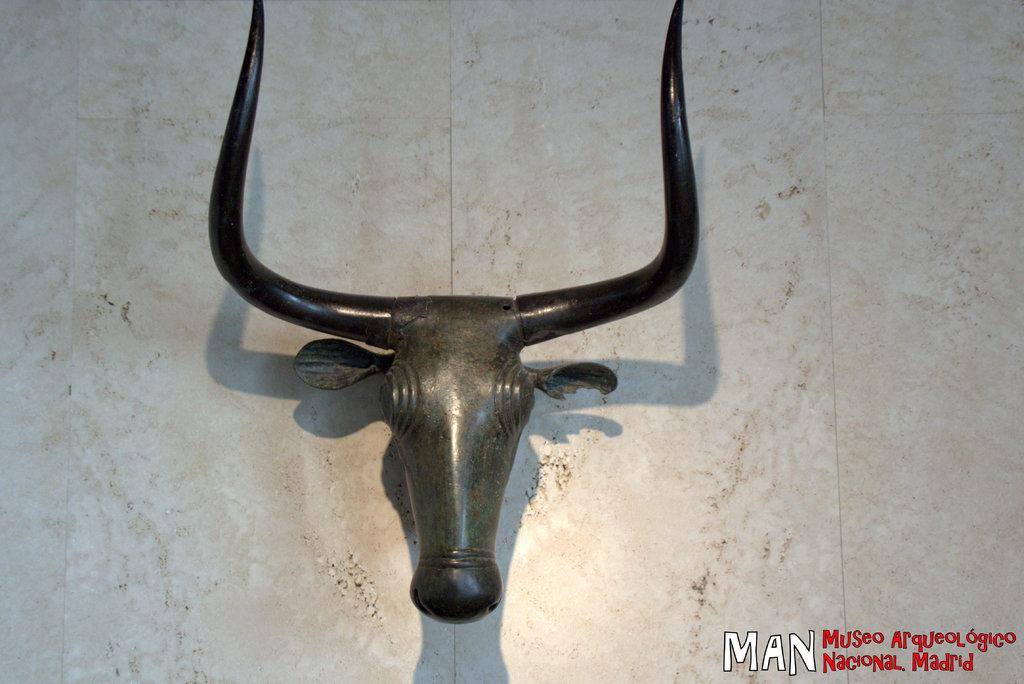What is the main subject of the image? The main subject of the image is an iron head of a bull. What specific features of the bull are visible in the image? The bull's horns are visible in the image. What is the color of the surface on which the bull's head and horns are placed? The bull's head and horns are on a white surface. Where is the text located in the image? The text is in the bottom right of the image. How many ducks are swimming in the water near the bull's head in the image? There are no ducks or water present in the image; it features an iron head of a bull on a white surface with text in the bottom right. What type of steel was used to create the bull's head in the image? The facts provided do not specify the type of steel used to create the bull's head, and there is no indication that the bull's head is made of steel. 